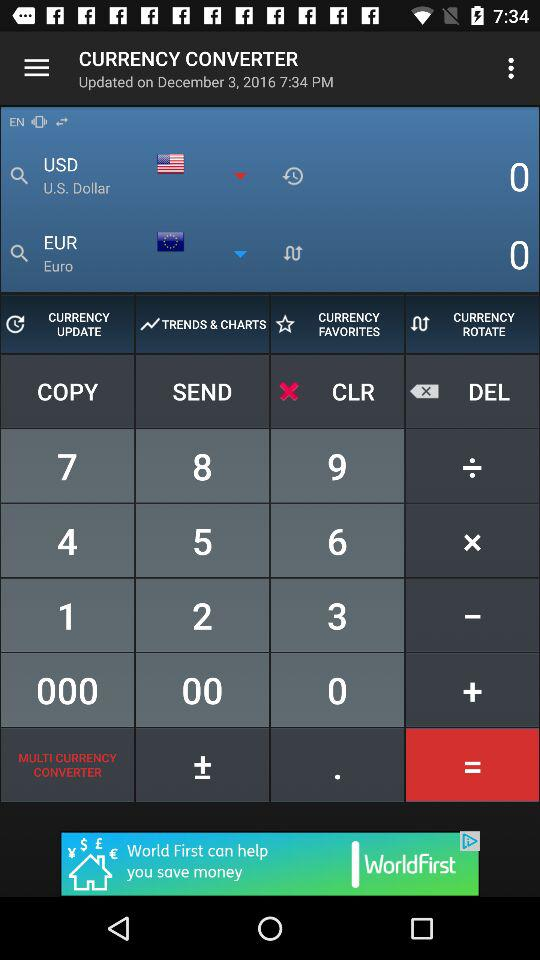On what date was the application "CURRENCY CONVERTER" updated? The application "CURRENCY CONVERTER" was updated on December 3, 2016. 